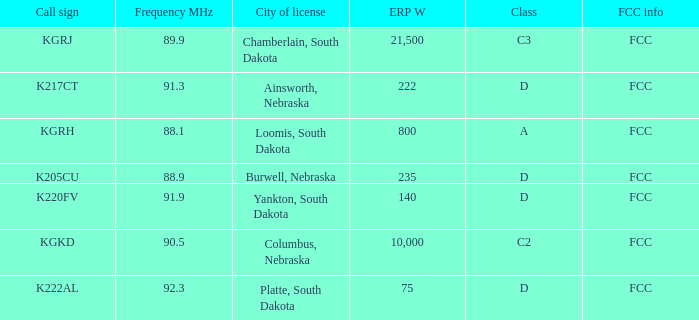What is the call sign with a 222 erp w? K217CT. I'm looking to parse the entire table for insights. Could you assist me with that? {'header': ['Call sign', 'Frequency MHz', 'City of license', 'ERP W', 'Class', 'FCC info'], 'rows': [['KGRJ', '89.9', 'Chamberlain, South Dakota', '21,500', 'C3', 'FCC'], ['K217CT', '91.3', 'Ainsworth, Nebraska', '222', 'D', 'FCC'], ['KGRH', '88.1', 'Loomis, South Dakota', '800', 'A', 'FCC'], ['K205CU', '88.9', 'Burwell, Nebraska', '235', 'D', 'FCC'], ['K220FV', '91.9', 'Yankton, South Dakota', '140', 'D', 'FCC'], ['KGKD', '90.5', 'Columbus, Nebraska', '10,000', 'C2', 'FCC'], ['K222AL', '92.3', 'Platte, South Dakota', '75', 'D', 'FCC']]} 